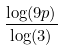<formula> <loc_0><loc_0><loc_500><loc_500>\frac { \log ( 9 p ) } { \log ( 3 ) }</formula> 